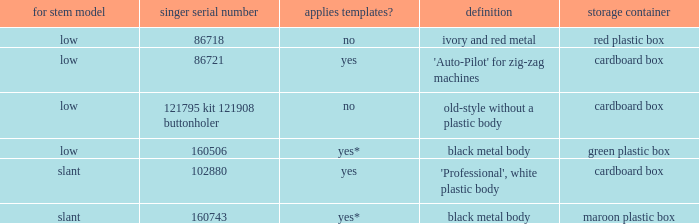What's the storage case of the buttonholer described as ivory and red metal? Red plastic box. 